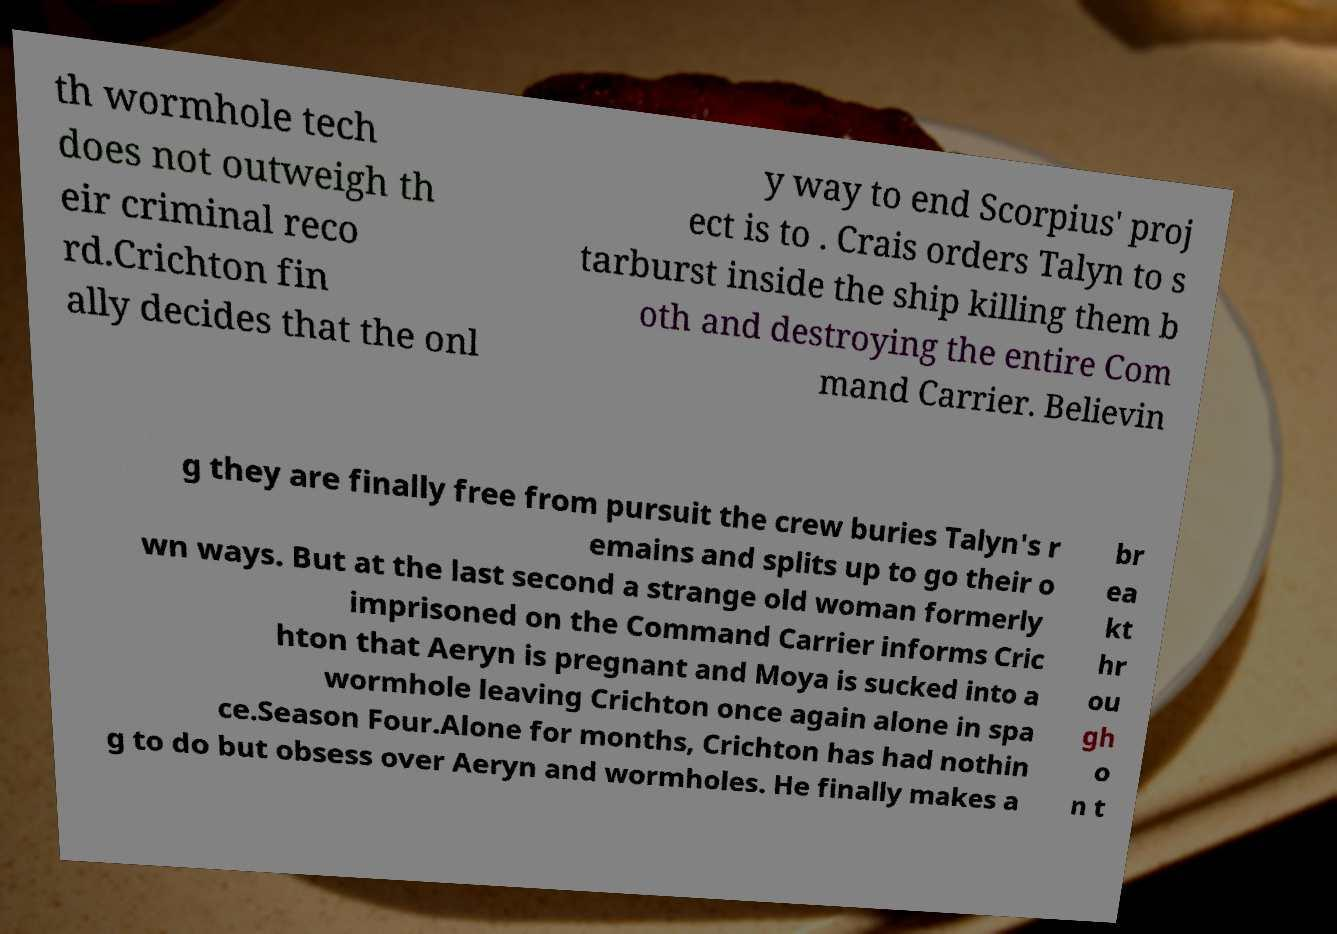What messages or text are displayed in this image? I need them in a readable, typed format. th wormhole tech does not outweigh th eir criminal reco rd.Crichton fin ally decides that the onl y way to end Scorpius' proj ect is to . Crais orders Talyn to s tarburst inside the ship killing them b oth and destroying the entire Com mand Carrier. Believin g they are finally free from pursuit the crew buries Talyn's r emains and splits up to go their o wn ways. But at the last second a strange old woman formerly imprisoned on the Command Carrier informs Cric hton that Aeryn is pregnant and Moya is sucked into a wormhole leaving Crichton once again alone in spa ce.Season Four.Alone for months, Crichton has had nothin g to do but obsess over Aeryn and wormholes. He finally makes a br ea kt hr ou gh o n t 